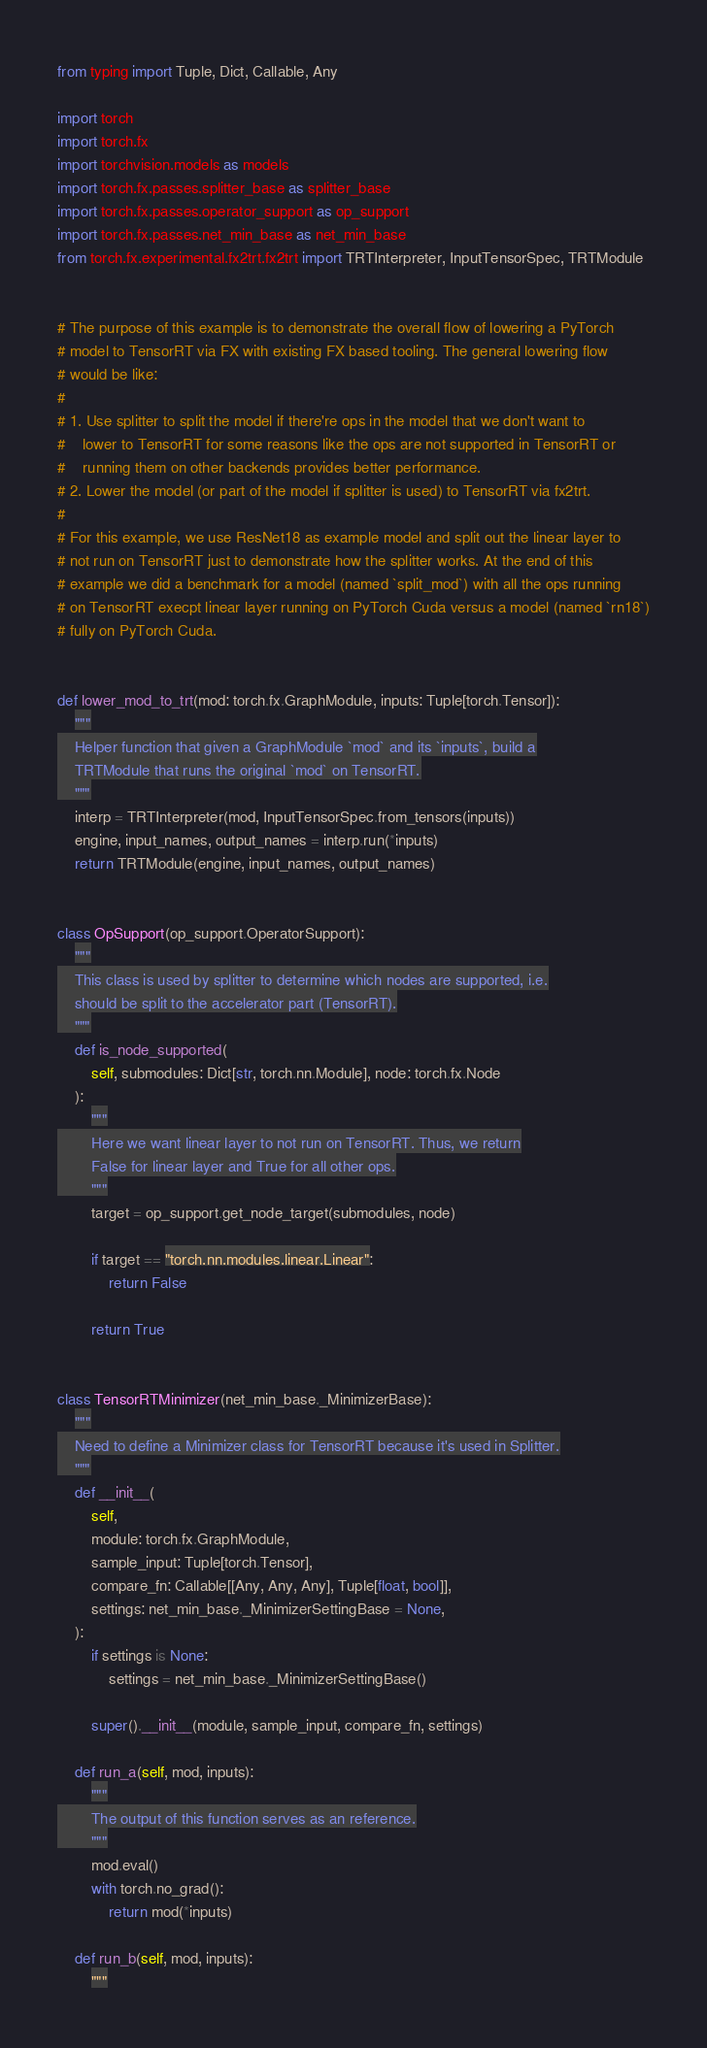<code> <loc_0><loc_0><loc_500><loc_500><_Python_>from typing import Tuple, Dict, Callable, Any

import torch
import torch.fx
import torchvision.models as models
import torch.fx.passes.splitter_base as splitter_base
import torch.fx.passes.operator_support as op_support
import torch.fx.passes.net_min_base as net_min_base
from torch.fx.experimental.fx2trt.fx2trt import TRTInterpreter, InputTensorSpec, TRTModule


# The purpose of this example is to demonstrate the overall flow of lowering a PyTorch
# model to TensorRT via FX with existing FX based tooling. The general lowering flow
# would be like:
#
# 1. Use splitter to split the model if there're ops in the model that we don't want to
#    lower to TensorRT for some reasons like the ops are not supported in TensorRT or
#    running them on other backends provides better performance.
# 2. Lower the model (or part of the model if splitter is used) to TensorRT via fx2trt.
#
# For this example, we use ResNet18 as example model and split out the linear layer to
# not run on TensorRT just to demonstrate how the splitter works. At the end of this
# example we did a benchmark for a model (named `split_mod`) with all the ops running
# on TensorRT execpt linear layer running on PyTorch Cuda versus a model (named `rn18`)
# fully on PyTorch Cuda.


def lower_mod_to_trt(mod: torch.fx.GraphModule, inputs: Tuple[torch.Tensor]):
    """
    Helper function that given a GraphModule `mod` and its `inputs`, build a
    TRTModule that runs the original `mod` on TensorRT.
    """
    interp = TRTInterpreter(mod, InputTensorSpec.from_tensors(inputs))
    engine, input_names, output_names = interp.run(*inputs)
    return TRTModule(engine, input_names, output_names)


class OpSupport(op_support.OperatorSupport):
    """
    This class is used by splitter to determine which nodes are supported, i.e.
    should be split to the accelerator part (TensorRT).
    """
    def is_node_supported(
        self, submodules: Dict[str, torch.nn.Module], node: torch.fx.Node
    ):
        """
        Here we want linear layer to not run on TensorRT. Thus, we return
        False for linear layer and True for all other ops.
        """
        target = op_support.get_node_target(submodules, node)

        if target == "torch.nn.modules.linear.Linear":
            return False

        return True


class TensorRTMinimizer(net_min_base._MinimizerBase):
    """
    Need to define a Minimizer class for TensorRT because it's used in Splitter.
    """
    def __init__(
        self,
        module: torch.fx.GraphModule,
        sample_input: Tuple[torch.Tensor],
        compare_fn: Callable[[Any, Any, Any], Tuple[float, bool]],
        settings: net_min_base._MinimizerSettingBase = None,
    ):
        if settings is None:
            settings = net_min_base._MinimizerSettingBase()

        super().__init__(module, sample_input, compare_fn, settings)

    def run_a(self, mod, inputs):
        """
        The output of this function serves as an reference.
        """
        mod.eval()
        with torch.no_grad():
            return mod(*inputs)

    def run_b(self, mod, inputs):
        """</code> 